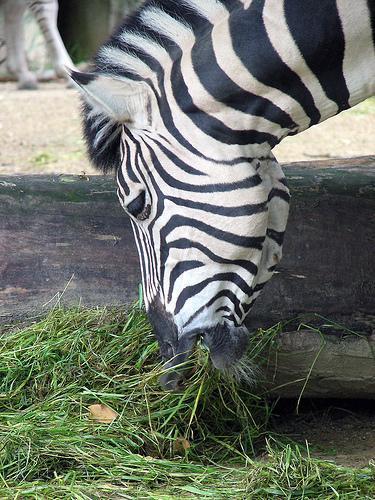How many zebras eating?
Give a very brief answer. 1. 